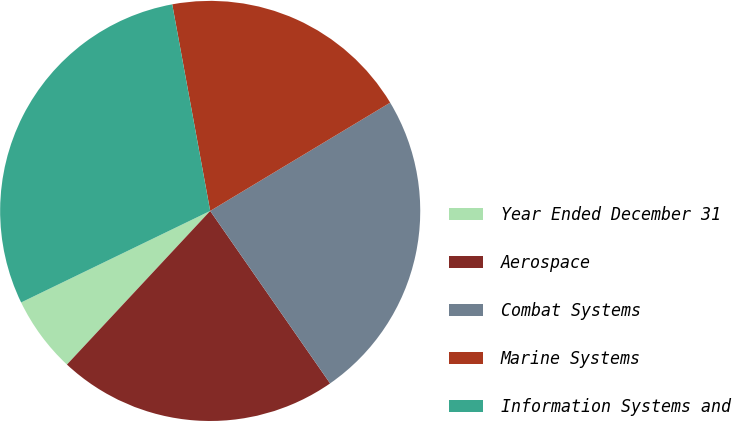Convert chart. <chart><loc_0><loc_0><loc_500><loc_500><pie_chart><fcel>Year Ended December 31<fcel>Aerospace<fcel>Combat Systems<fcel>Marine Systems<fcel>Information Systems and<nl><fcel>5.88%<fcel>21.61%<fcel>23.95%<fcel>19.27%<fcel>29.28%<nl></chart> 